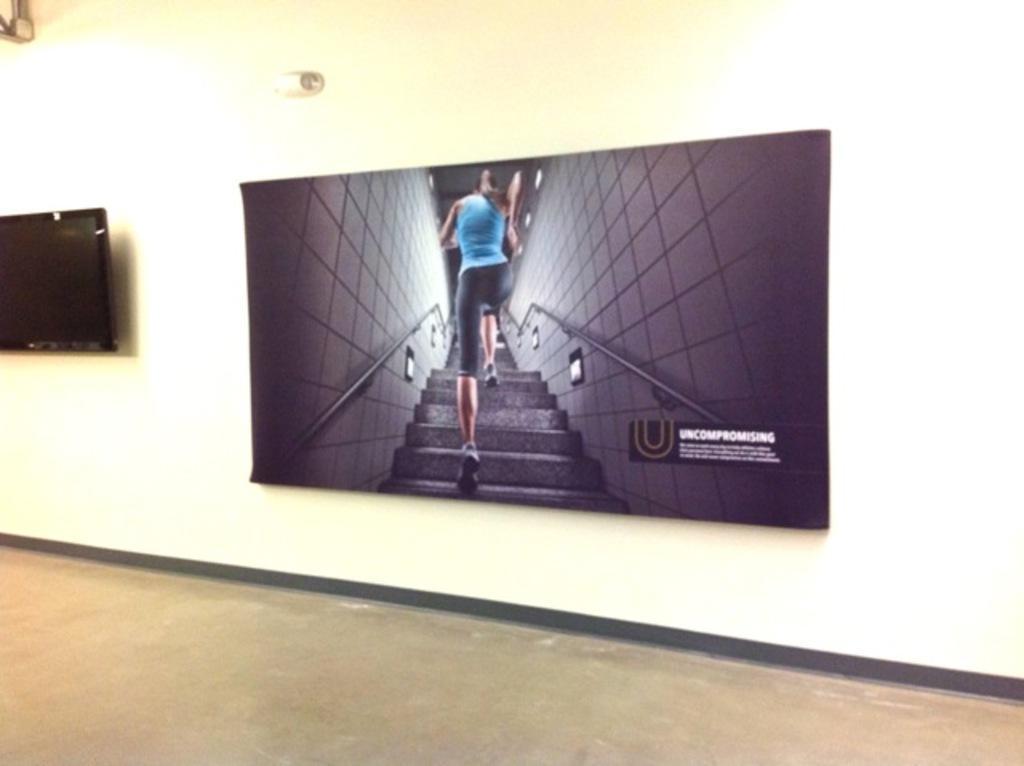Could you give a brief overview of what you see in this image? In the middle of this image, there is a screen attached to the wall. Beside this screen, there is another screen attached to the wall. Above these two screens, there are two objects attached to the walls. At the bottom of this image, there is a floor of the building. 